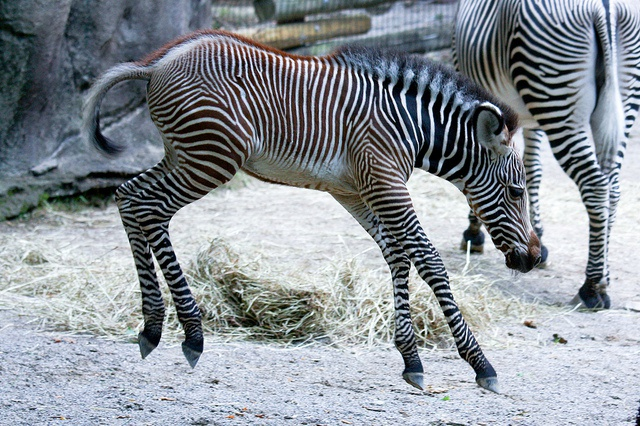Describe the objects in this image and their specific colors. I can see zebra in black, gray, darkgray, and lightgray tones and zebra in black, lavender, darkgray, and gray tones in this image. 